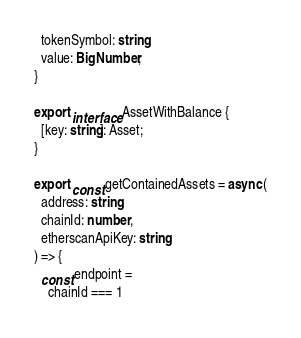<code> <loc_0><loc_0><loc_500><loc_500><_TypeScript_>  tokenSymbol: string;
  value: BigNumber;
}

export interface AssetWithBalance {
  [key: string]: Asset;
}

export const getContainedAssets = async (
  address: string,
  chainId: number,
  etherscanApiKey: string
) => {
  const endpoint =
    chainId === 1</code> 